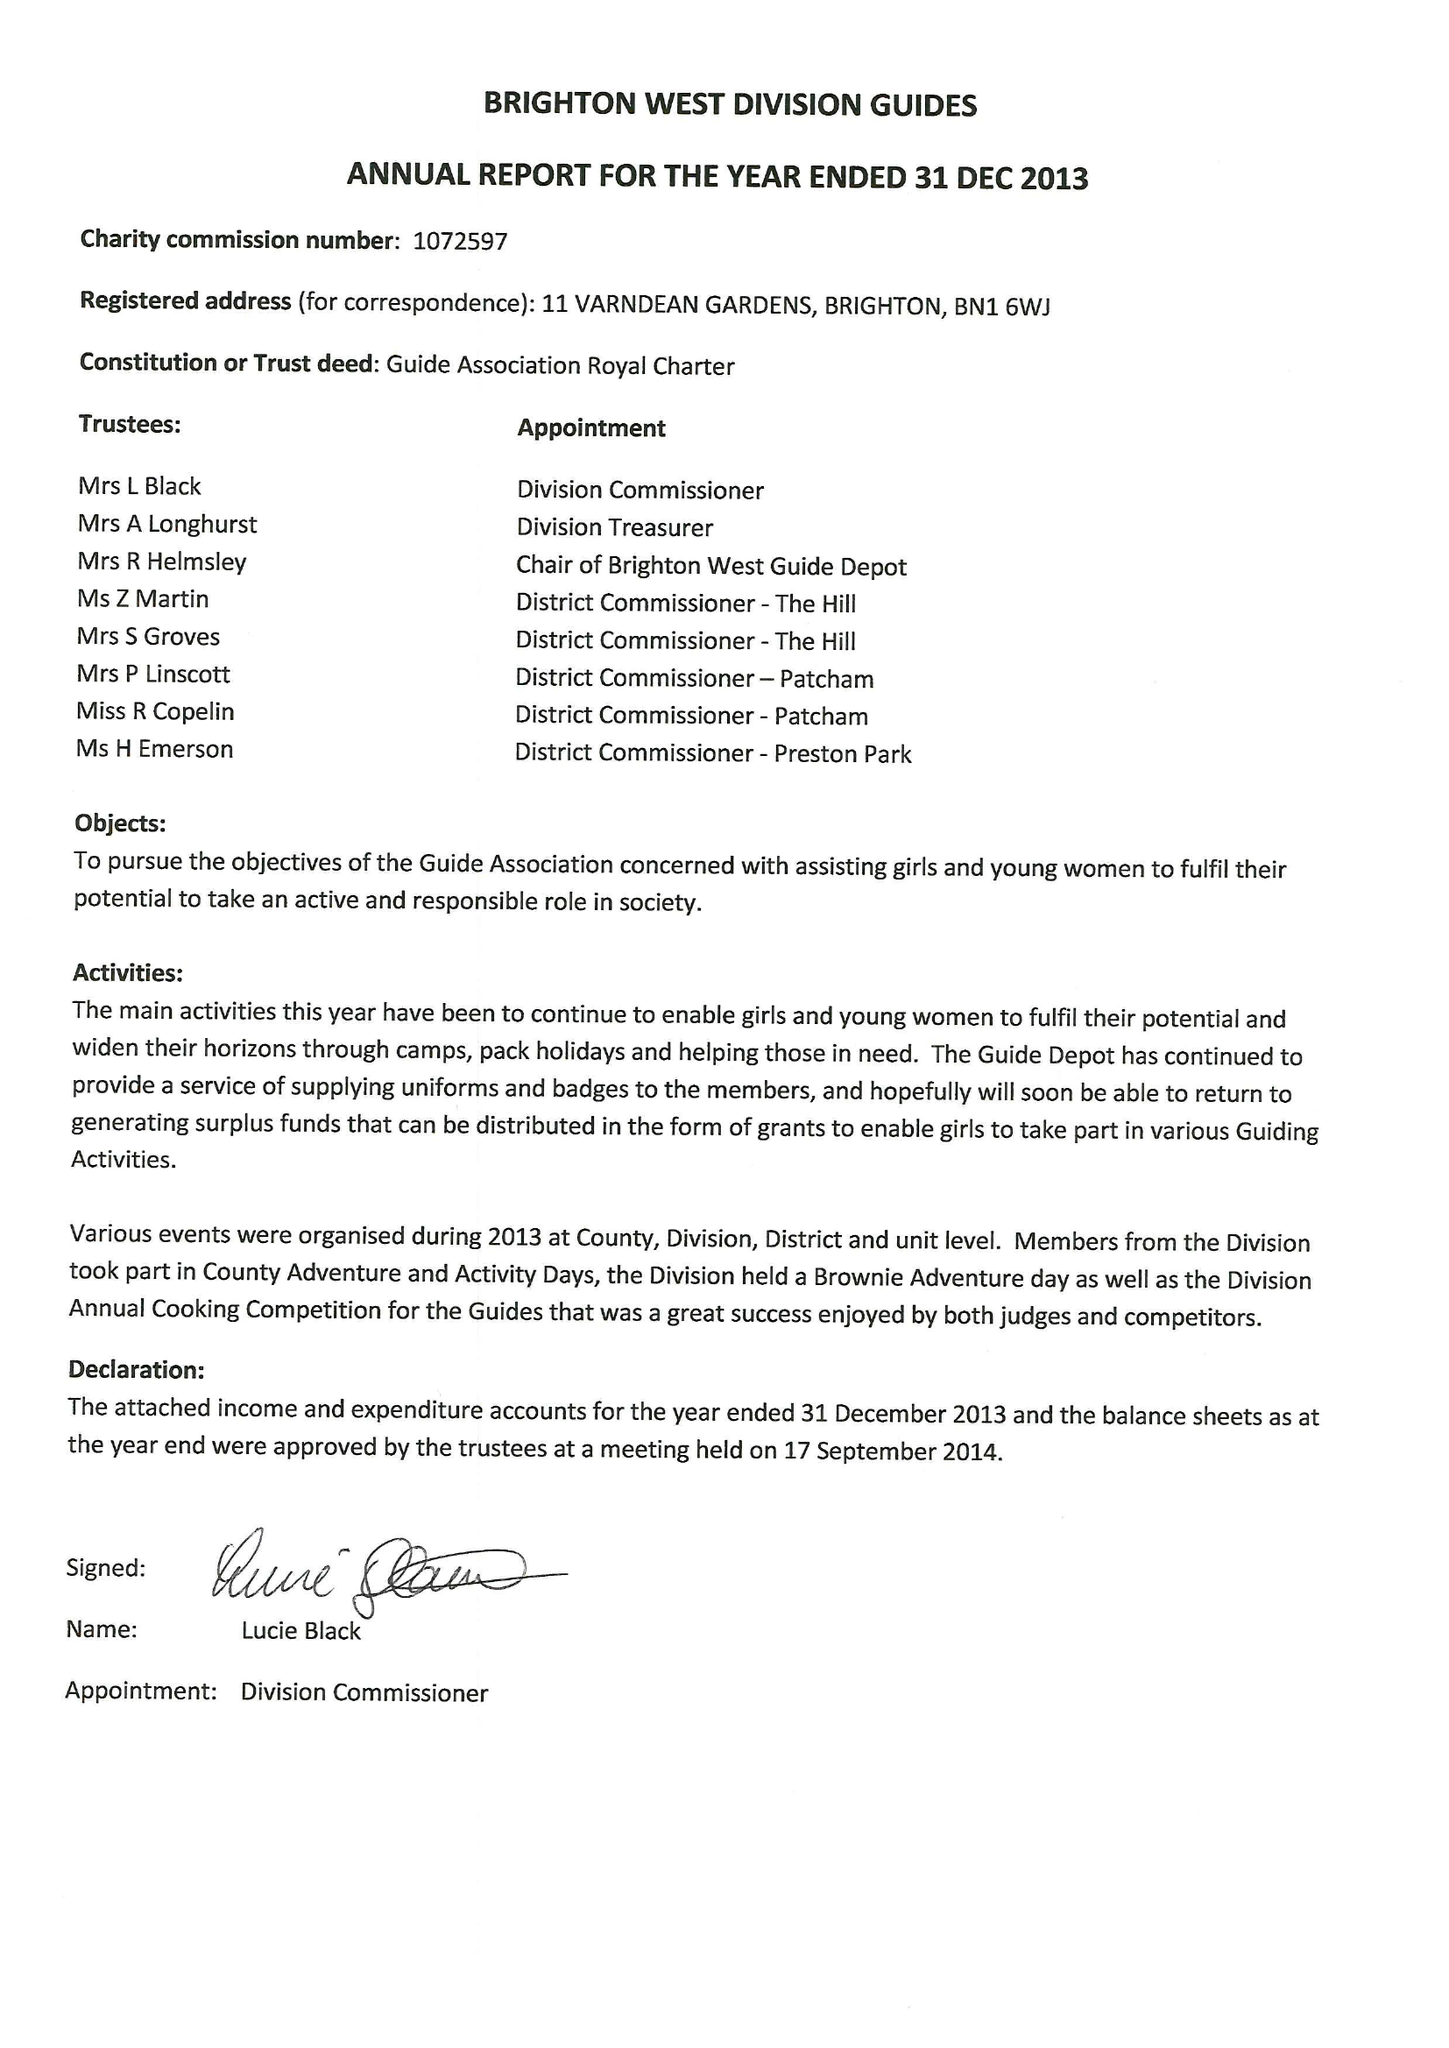What is the value for the spending_annually_in_british_pounds?
Answer the question using a single word or phrase. 31494.00 